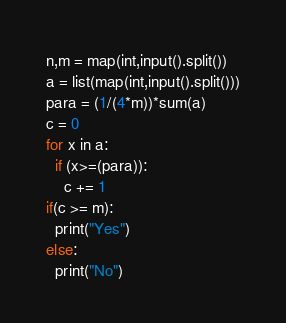Convert code to text. <code><loc_0><loc_0><loc_500><loc_500><_Python_>n,m = map(int,input().split())
a = list(map(int,input().split()))
para = (1/(4*m))*sum(a)
c = 0
for x in a:
  if (x>=(para)):
    c += 1
if(c >= m):
  print("Yes")
else:
  print("No")</code> 